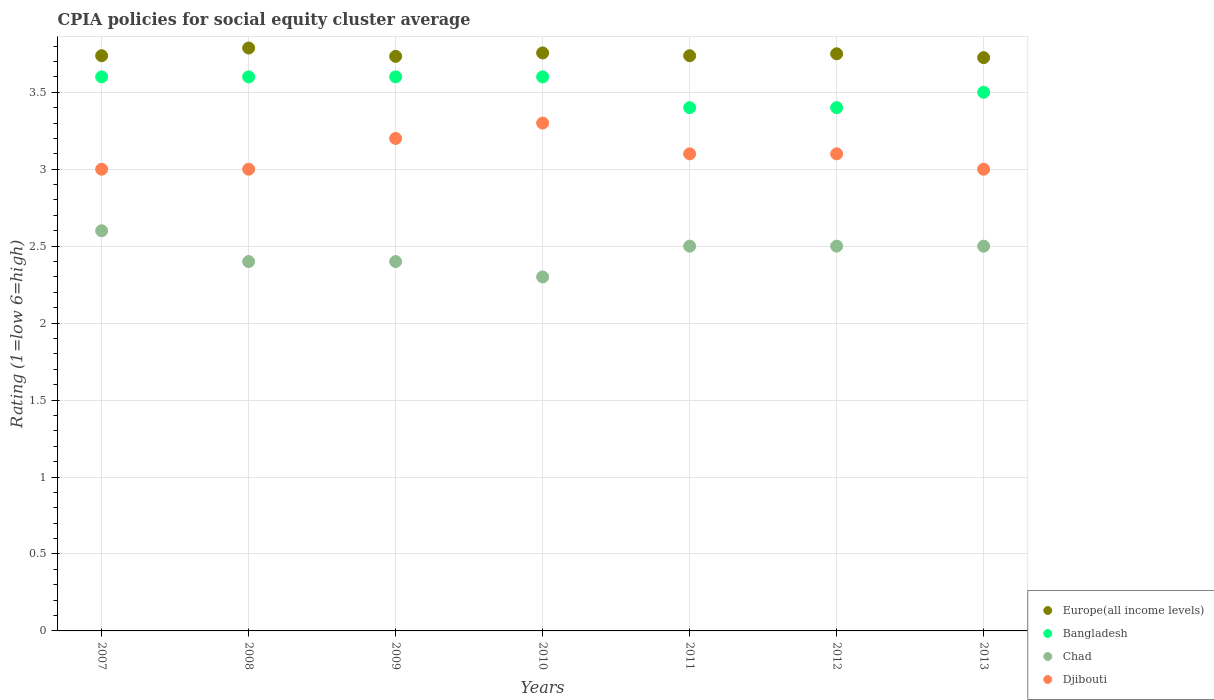How many different coloured dotlines are there?
Your response must be concise. 4. Across all years, what is the minimum CPIA rating in Bangladesh?
Keep it short and to the point. 3.4. In which year was the CPIA rating in Djibouti maximum?
Make the answer very short. 2010. What is the total CPIA rating in Europe(all income levels) in the graph?
Offer a very short reply. 26.23. What is the difference between the CPIA rating in Europe(all income levels) in 2009 and that in 2010?
Provide a short and direct response. -0.02. What is the difference between the CPIA rating in Chad in 2007 and the CPIA rating in Europe(all income levels) in 2012?
Your answer should be compact. -1.15. What is the average CPIA rating in Chad per year?
Ensure brevity in your answer.  2.46. In the year 2010, what is the difference between the CPIA rating in Europe(all income levels) and CPIA rating in Djibouti?
Keep it short and to the point. 0.46. Is the difference between the CPIA rating in Europe(all income levels) in 2011 and 2013 greater than the difference between the CPIA rating in Djibouti in 2011 and 2013?
Provide a succinct answer. No. What is the difference between the highest and the second highest CPIA rating in Chad?
Offer a terse response. 0.1. What is the difference between the highest and the lowest CPIA rating in Djibouti?
Provide a short and direct response. 0.3. Is the sum of the CPIA rating in Bangladesh in 2007 and 2012 greater than the maximum CPIA rating in Chad across all years?
Ensure brevity in your answer.  Yes. Is it the case that in every year, the sum of the CPIA rating in Europe(all income levels) and CPIA rating in Chad  is greater than the sum of CPIA rating in Bangladesh and CPIA rating in Djibouti?
Ensure brevity in your answer.  No. Is it the case that in every year, the sum of the CPIA rating in Chad and CPIA rating in Bangladesh  is greater than the CPIA rating in Europe(all income levels)?
Your answer should be very brief. Yes. Does the CPIA rating in Bangladesh monotonically increase over the years?
Offer a terse response. No. Is the CPIA rating in Europe(all income levels) strictly greater than the CPIA rating in Djibouti over the years?
Offer a terse response. Yes. Is the CPIA rating in Europe(all income levels) strictly less than the CPIA rating in Djibouti over the years?
Offer a very short reply. No. How many years are there in the graph?
Your answer should be compact. 7. Are the values on the major ticks of Y-axis written in scientific E-notation?
Your answer should be very brief. No. Where does the legend appear in the graph?
Keep it short and to the point. Bottom right. How many legend labels are there?
Your answer should be very brief. 4. How are the legend labels stacked?
Your answer should be very brief. Vertical. What is the title of the graph?
Your answer should be very brief. CPIA policies for social equity cluster average. Does "Djibouti" appear as one of the legend labels in the graph?
Keep it short and to the point. Yes. What is the label or title of the X-axis?
Provide a short and direct response. Years. What is the label or title of the Y-axis?
Provide a short and direct response. Rating (1=low 6=high). What is the Rating (1=low 6=high) in Europe(all income levels) in 2007?
Provide a short and direct response. 3.74. What is the Rating (1=low 6=high) of Europe(all income levels) in 2008?
Offer a very short reply. 3.79. What is the Rating (1=low 6=high) in Bangladesh in 2008?
Your answer should be very brief. 3.6. What is the Rating (1=low 6=high) of Europe(all income levels) in 2009?
Keep it short and to the point. 3.73. What is the Rating (1=low 6=high) in Europe(all income levels) in 2010?
Ensure brevity in your answer.  3.76. What is the Rating (1=low 6=high) in Europe(all income levels) in 2011?
Keep it short and to the point. 3.74. What is the Rating (1=low 6=high) of Europe(all income levels) in 2012?
Keep it short and to the point. 3.75. What is the Rating (1=low 6=high) of Bangladesh in 2012?
Provide a succinct answer. 3.4. What is the Rating (1=low 6=high) of Chad in 2012?
Your answer should be compact. 2.5. What is the Rating (1=low 6=high) in Djibouti in 2012?
Offer a very short reply. 3.1. What is the Rating (1=low 6=high) of Europe(all income levels) in 2013?
Your answer should be compact. 3.73. What is the Rating (1=low 6=high) of Bangladesh in 2013?
Offer a very short reply. 3.5. What is the Rating (1=low 6=high) of Chad in 2013?
Your response must be concise. 2.5. What is the Rating (1=low 6=high) in Djibouti in 2013?
Make the answer very short. 3. Across all years, what is the maximum Rating (1=low 6=high) in Europe(all income levels)?
Provide a succinct answer. 3.79. Across all years, what is the minimum Rating (1=low 6=high) of Europe(all income levels)?
Offer a very short reply. 3.73. Across all years, what is the minimum Rating (1=low 6=high) of Chad?
Your answer should be very brief. 2.3. Across all years, what is the minimum Rating (1=low 6=high) in Djibouti?
Give a very brief answer. 3. What is the total Rating (1=low 6=high) in Europe(all income levels) in the graph?
Keep it short and to the point. 26.23. What is the total Rating (1=low 6=high) of Bangladesh in the graph?
Provide a short and direct response. 24.7. What is the total Rating (1=low 6=high) in Djibouti in the graph?
Provide a succinct answer. 21.7. What is the difference between the Rating (1=low 6=high) of Europe(all income levels) in 2007 and that in 2008?
Offer a terse response. -0.05. What is the difference between the Rating (1=low 6=high) in Bangladesh in 2007 and that in 2008?
Offer a very short reply. 0. What is the difference between the Rating (1=low 6=high) of Chad in 2007 and that in 2008?
Ensure brevity in your answer.  0.2. What is the difference between the Rating (1=low 6=high) of Europe(all income levels) in 2007 and that in 2009?
Make the answer very short. 0. What is the difference between the Rating (1=low 6=high) of Bangladesh in 2007 and that in 2009?
Offer a very short reply. 0. What is the difference between the Rating (1=low 6=high) in Chad in 2007 and that in 2009?
Keep it short and to the point. 0.2. What is the difference between the Rating (1=low 6=high) of Europe(all income levels) in 2007 and that in 2010?
Your response must be concise. -0.02. What is the difference between the Rating (1=low 6=high) in Bangladesh in 2007 and that in 2010?
Keep it short and to the point. 0. What is the difference between the Rating (1=low 6=high) in Chad in 2007 and that in 2010?
Make the answer very short. 0.3. What is the difference between the Rating (1=low 6=high) in Chad in 2007 and that in 2011?
Give a very brief answer. 0.1. What is the difference between the Rating (1=low 6=high) in Djibouti in 2007 and that in 2011?
Ensure brevity in your answer.  -0.1. What is the difference between the Rating (1=low 6=high) in Europe(all income levels) in 2007 and that in 2012?
Offer a very short reply. -0.01. What is the difference between the Rating (1=low 6=high) of Bangladesh in 2007 and that in 2012?
Provide a short and direct response. 0.2. What is the difference between the Rating (1=low 6=high) in Europe(all income levels) in 2007 and that in 2013?
Provide a succinct answer. 0.01. What is the difference between the Rating (1=low 6=high) of Chad in 2007 and that in 2013?
Give a very brief answer. 0.1. What is the difference between the Rating (1=low 6=high) of Europe(all income levels) in 2008 and that in 2009?
Your answer should be compact. 0.05. What is the difference between the Rating (1=low 6=high) in Bangladesh in 2008 and that in 2009?
Your answer should be compact. 0. What is the difference between the Rating (1=low 6=high) in Europe(all income levels) in 2008 and that in 2010?
Your answer should be compact. 0.03. What is the difference between the Rating (1=low 6=high) of Djibouti in 2008 and that in 2010?
Your answer should be compact. -0.3. What is the difference between the Rating (1=low 6=high) in Bangladesh in 2008 and that in 2011?
Your response must be concise. 0.2. What is the difference between the Rating (1=low 6=high) of Chad in 2008 and that in 2011?
Give a very brief answer. -0.1. What is the difference between the Rating (1=low 6=high) in Europe(all income levels) in 2008 and that in 2012?
Provide a succinct answer. 0.04. What is the difference between the Rating (1=low 6=high) of Chad in 2008 and that in 2012?
Provide a succinct answer. -0.1. What is the difference between the Rating (1=low 6=high) of Europe(all income levels) in 2008 and that in 2013?
Give a very brief answer. 0.06. What is the difference between the Rating (1=low 6=high) in Chad in 2008 and that in 2013?
Offer a terse response. -0.1. What is the difference between the Rating (1=low 6=high) of Djibouti in 2008 and that in 2013?
Your answer should be compact. 0. What is the difference between the Rating (1=low 6=high) in Europe(all income levels) in 2009 and that in 2010?
Make the answer very short. -0.02. What is the difference between the Rating (1=low 6=high) of Bangladesh in 2009 and that in 2010?
Provide a short and direct response. 0. What is the difference between the Rating (1=low 6=high) in Djibouti in 2009 and that in 2010?
Offer a very short reply. -0.1. What is the difference between the Rating (1=low 6=high) in Europe(all income levels) in 2009 and that in 2011?
Keep it short and to the point. -0. What is the difference between the Rating (1=low 6=high) in Chad in 2009 and that in 2011?
Make the answer very short. -0.1. What is the difference between the Rating (1=low 6=high) of Djibouti in 2009 and that in 2011?
Offer a terse response. 0.1. What is the difference between the Rating (1=low 6=high) of Europe(all income levels) in 2009 and that in 2012?
Provide a succinct answer. -0.02. What is the difference between the Rating (1=low 6=high) of Chad in 2009 and that in 2012?
Offer a terse response. -0.1. What is the difference between the Rating (1=low 6=high) of Djibouti in 2009 and that in 2012?
Your answer should be very brief. 0.1. What is the difference between the Rating (1=low 6=high) in Europe(all income levels) in 2009 and that in 2013?
Make the answer very short. 0.01. What is the difference between the Rating (1=low 6=high) in Djibouti in 2009 and that in 2013?
Keep it short and to the point. 0.2. What is the difference between the Rating (1=low 6=high) of Europe(all income levels) in 2010 and that in 2011?
Make the answer very short. 0.02. What is the difference between the Rating (1=low 6=high) in Chad in 2010 and that in 2011?
Give a very brief answer. -0.2. What is the difference between the Rating (1=low 6=high) in Europe(all income levels) in 2010 and that in 2012?
Keep it short and to the point. 0.01. What is the difference between the Rating (1=low 6=high) in Chad in 2010 and that in 2012?
Give a very brief answer. -0.2. What is the difference between the Rating (1=low 6=high) of Djibouti in 2010 and that in 2012?
Offer a very short reply. 0.2. What is the difference between the Rating (1=low 6=high) in Europe(all income levels) in 2010 and that in 2013?
Ensure brevity in your answer.  0.03. What is the difference between the Rating (1=low 6=high) in Chad in 2010 and that in 2013?
Your answer should be compact. -0.2. What is the difference between the Rating (1=low 6=high) of Europe(all income levels) in 2011 and that in 2012?
Ensure brevity in your answer.  -0.01. What is the difference between the Rating (1=low 6=high) in Chad in 2011 and that in 2012?
Provide a succinct answer. 0. What is the difference between the Rating (1=low 6=high) of Djibouti in 2011 and that in 2012?
Your response must be concise. 0. What is the difference between the Rating (1=low 6=high) of Europe(all income levels) in 2011 and that in 2013?
Give a very brief answer. 0.01. What is the difference between the Rating (1=low 6=high) in Bangladesh in 2011 and that in 2013?
Your answer should be compact. -0.1. What is the difference between the Rating (1=low 6=high) of Djibouti in 2011 and that in 2013?
Provide a short and direct response. 0.1. What is the difference between the Rating (1=low 6=high) of Europe(all income levels) in 2012 and that in 2013?
Your answer should be very brief. 0.03. What is the difference between the Rating (1=low 6=high) in Europe(all income levels) in 2007 and the Rating (1=low 6=high) in Bangladesh in 2008?
Keep it short and to the point. 0.14. What is the difference between the Rating (1=low 6=high) in Europe(all income levels) in 2007 and the Rating (1=low 6=high) in Chad in 2008?
Keep it short and to the point. 1.34. What is the difference between the Rating (1=low 6=high) of Europe(all income levels) in 2007 and the Rating (1=low 6=high) of Djibouti in 2008?
Your response must be concise. 0.74. What is the difference between the Rating (1=low 6=high) in Bangladesh in 2007 and the Rating (1=low 6=high) in Djibouti in 2008?
Provide a short and direct response. 0.6. What is the difference between the Rating (1=low 6=high) in Chad in 2007 and the Rating (1=low 6=high) in Djibouti in 2008?
Your response must be concise. -0.4. What is the difference between the Rating (1=low 6=high) of Europe(all income levels) in 2007 and the Rating (1=low 6=high) of Bangladesh in 2009?
Offer a very short reply. 0.14. What is the difference between the Rating (1=low 6=high) in Europe(all income levels) in 2007 and the Rating (1=low 6=high) in Chad in 2009?
Offer a terse response. 1.34. What is the difference between the Rating (1=low 6=high) of Europe(all income levels) in 2007 and the Rating (1=low 6=high) of Djibouti in 2009?
Make the answer very short. 0.54. What is the difference between the Rating (1=low 6=high) of Bangladesh in 2007 and the Rating (1=low 6=high) of Djibouti in 2009?
Provide a succinct answer. 0.4. What is the difference between the Rating (1=low 6=high) of Chad in 2007 and the Rating (1=low 6=high) of Djibouti in 2009?
Offer a very short reply. -0.6. What is the difference between the Rating (1=low 6=high) in Europe(all income levels) in 2007 and the Rating (1=low 6=high) in Bangladesh in 2010?
Offer a very short reply. 0.14. What is the difference between the Rating (1=low 6=high) of Europe(all income levels) in 2007 and the Rating (1=low 6=high) of Chad in 2010?
Make the answer very short. 1.44. What is the difference between the Rating (1=low 6=high) of Europe(all income levels) in 2007 and the Rating (1=low 6=high) of Djibouti in 2010?
Keep it short and to the point. 0.44. What is the difference between the Rating (1=low 6=high) in Bangladesh in 2007 and the Rating (1=low 6=high) in Chad in 2010?
Offer a terse response. 1.3. What is the difference between the Rating (1=low 6=high) of Europe(all income levels) in 2007 and the Rating (1=low 6=high) of Bangladesh in 2011?
Provide a short and direct response. 0.34. What is the difference between the Rating (1=low 6=high) of Europe(all income levels) in 2007 and the Rating (1=low 6=high) of Chad in 2011?
Your response must be concise. 1.24. What is the difference between the Rating (1=low 6=high) in Europe(all income levels) in 2007 and the Rating (1=low 6=high) in Djibouti in 2011?
Provide a short and direct response. 0.64. What is the difference between the Rating (1=low 6=high) in Bangladesh in 2007 and the Rating (1=low 6=high) in Chad in 2011?
Your answer should be compact. 1.1. What is the difference between the Rating (1=low 6=high) of Europe(all income levels) in 2007 and the Rating (1=low 6=high) of Bangladesh in 2012?
Provide a succinct answer. 0.34. What is the difference between the Rating (1=low 6=high) in Europe(all income levels) in 2007 and the Rating (1=low 6=high) in Chad in 2012?
Keep it short and to the point. 1.24. What is the difference between the Rating (1=low 6=high) in Europe(all income levels) in 2007 and the Rating (1=low 6=high) in Djibouti in 2012?
Provide a short and direct response. 0.64. What is the difference between the Rating (1=low 6=high) of Bangladesh in 2007 and the Rating (1=low 6=high) of Chad in 2012?
Your response must be concise. 1.1. What is the difference between the Rating (1=low 6=high) in Chad in 2007 and the Rating (1=low 6=high) in Djibouti in 2012?
Make the answer very short. -0.5. What is the difference between the Rating (1=low 6=high) of Europe(all income levels) in 2007 and the Rating (1=low 6=high) of Bangladesh in 2013?
Keep it short and to the point. 0.24. What is the difference between the Rating (1=low 6=high) of Europe(all income levels) in 2007 and the Rating (1=low 6=high) of Chad in 2013?
Keep it short and to the point. 1.24. What is the difference between the Rating (1=low 6=high) in Europe(all income levels) in 2007 and the Rating (1=low 6=high) in Djibouti in 2013?
Ensure brevity in your answer.  0.74. What is the difference between the Rating (1=low 6=high) in Europe(all income levels) in 2008 and the Rating (1=low 6=high) in Bangladesh in 2009?
Offer a very short reply. 0.19. What is the difference between the Rating (1=low 6=high) in Europe(all income levels) in 2008 and the Rating (1=low 6=high) in Chad in 2009?
Offer a terse response. 1.39. What is the difference between the Rating (1=low 6=high) in Europe(all income levels) in 2008 and the Rating (1=low 6=high) in Djibouti in 2009?
Your response must be concise. 0.59. What is the difference between the Rating (1=low 6=high) of Bangladesh in 2008 and the Rating (1=low 6=high) of Djibouti in 2009?
Your answer should be compact. 0.4. What is the difference between the Rating (1=low 6=high) of Chad in 2008 and the Rating (1=low 6=high) of Djibouti in 2009?
Make the answer very short. -0.8. What is the difference between the Rating (1=low 6=high) in Europe(all income levels) in 2008 and the Rating (1=low 6=high) in Bangladesh in 2010?
Provide a short and direct response. 0.19. What is the difference between the Rating (1=low 6=high) of Europe(all income levels) in 2008 and the Rating (1=low 6=high) of Chad in 2010?
Keep it short and to the point. 1.49. What is the difference between the Rating (1=low 6=high) in Europe(all income levels) in 2008 and the Rating (1=low 6=high) in Djibouti in 2010?
Make the answer very short. 0.49. What is the difference between the Rating (1=low 6=high) of Bangladesh in 2008 and the Rating (1=low 6=high) of Chad in 2010?
Provide a short and direct response. 1.3. What is the difference between the Rating (1=low 6=high) of Europe(all income levels) in 2008 and the Rating (1=low 6=high) of Bangladesh in 2011?
Your answer should be very brief. 0.39. What is the difference between the Rating (1=low 6=high) of Europe(all income levels) in 2008 and the Rating (1=low 6=high) of Chad in 2011?
Make the answer very short. 1.29. What is the difference between the Rating (1=low 6=high) of Europe(all income levels) in 2008 and the Rating (1=low 6=high) of Djibouti in 2011?
Provide a short and direct response. 0.69. What is the difference between the Rating (1=low 6=high) in Bangladesh in 2008 and the Rating (1=low 6=high) in Chad in 2011?
Make the answer very short. 1.1. What is the difference between the Rating (1=low 6=high) in Europe(all income levels) in 2008 and the Rating (1=low 6=high) in Bangladesh in 2012?
Your answer should be very brief. 0.39. What is the difference between the Rating (1=low 6=high) of Europe(all income levels) in 2008 and the Rating (1=low 6=high) of Chad in 2012?
Offer a terse response. 1.29. What is the difference between the Rating (1=low 6=high) in Europe(all income levels) in 2008 and the Rating (1=low 6=high) in Djibouti in 2012?
Give a very brief answer. 0.69. What is the difference between the Rating (1=low 6=high) in Bangladesh in 2008 and the Rating (1=low 6=high) in Djibouti in 2012?
Your response must be concise. 0.5. What is the difference between the Rating (1=low 6=high) in Europe(all income levels) in 2008 and the Rating (1=low 6=high) in Bangladesh in 2013?
Offer a terse response. 0.29. What is the difference between the Rating (1=low 6=high) of Europe(all income levels) in 2008 and the Rating (1=low 6=high) of Chad in 2013?
Give a very brief answer. 1.29. What is the difference between the Rating (1=low 6=high) in Europe(all income levels) in 2008 and the Rating (1=low 6=high) in Djibouti in 2013?
Your answer should be very brief. 0.79. What is the difference between the Rating (1=low 6=high) in Chad in 2008 and the Rating (1=low 6=high) in Djibouti in 2013?
Provide a succinct answer. -0.6. What is the difference between the Rating (1=low 6=high) of Europe(all income levels) in 2009 and the Rating (1=low 6=high) of Bangladesh in 2010?
Offer a terse response. 0.13. What is the difference between the Rating (1=low 6=high) in Europe(all income levels) in 2009 and the Rating (1=low 6=high) in Chad in 2010?
Offer a very short reply. 1.43. What is the difference between the Rating (1=low 6=high) of Europe(all income levels) in 2009 and the Rating (1=low 6=high) of Djibouti in 2010?
Your response must be concise. 0.43. What is the difference between the Rating (1=low 6=high) in Bangladesh in 2009 and the Rating (1=low 6=high) in Djibouti in 2010?
Keep it short and to the point. 0.3. What is the difference between the Rating (1=low 6=high) in Chad in 2009 and the Rating (1=low 6=high) in Djibouti in 2010?
Keep it short and to the point. -0.9. What is the difference between the Rating (1=low 6=high) of Europe(all income levels) in 2009 and the Rating (1=low 6=high) of Bangladesh in 2011?
Your response must be concise. 0.33. What is the difference between the Rating (1=low 6=high) of Europe(all income levels) in 2009 and the Rating (1=low 6=high) of Chad in 2011?
Your response must be concise. 1.23. What is the difference between the Rating (1=low 6=high) in Europe(all income levels) in 2009 and the Rating (1=low 6=high) in Djibouti in 2011?
Offer a very short reply. 0.63. What is the difference between the Rating (1=low 6=high) of Bangladesh in 2009 and the Rating (1=low 6=high) of Chad in 2011?
Make the answer very short. 1.1. What is the difference between the Rating (1=low 6=high) in Bangladesh in 2009 and the Rating (1=low 6=high) in Djibouti in 2011?
Your answer should be compact. 0.5. What is the difference between the Rating (1=low 6=high) in Europe(all income levels) in 2009 and the Rating (1=low 6=high) in Chad in 2012?
Ensure brevity in your answer.  1.23. What is the difference between the Rating (1=low 6=high) of Europe(all income levels) in 2009 and the Rating (1=low 6=high) of Djibouti in 2012?
Give a very brief answer. 0.63. What is the difference between the Rating (1=low 6=high) in Bangladesh in 2009 and the Rating (1=low 6=high) in Chad in 2012?
Your answer should be compact. 1.1. What is the difference between the Rating (1=low 6=high) of Chad in 2009 and the Rating (1=low 6=high) of Djibouti in 2012?
Provide a succinct answer. -0.7. What is the difference between the Rating (1=low 6=high) in Europe(all income levels) in 2009 and the Rating (1=low 6=high) in Bangladesh in 2013?
Make the answer very short. 0.23. What is the difference between the Rating (1=low 6=high) in Europe(all income levels) in 2009 and the Rating (1=low 6=high) in Chad in 2013?
Offer a terse response. 1.23. What is the difference between the Rating (1=low 6=high) of Europe(all income levels) in 2009 and the Rating (1=low 6=high) of Djibouti in 2013?
Offer a terse response. 0.73. What is the difference between the Rating (1=low 6=high) in Bangladesh in 2009 and the Rating (1=low 6=high) in Chad in 2013?
Ensure brevity in your answer.  1.1. What is the difference between the Rating (1=low 6=high) in Bangladesh in 2009 and the Rating (1=low 6=high) in Djibouti in 2013?
Make the answer very short. 0.6. What is the difference between the Rating (1=low 6=high) of Chad in 2009 and the Rating (1=low 6=high) of Djibouti in 2013?
Give a very brief answer. -0.6. What is the difference between the Rating (1=low 6=high) in Europe(all income levels) in 2010 and the Rating (1=low 6=high) in Bangladesh in 2011?
Make the answer very short. 0.36. What is the difference between the Rating (1=low 6=high) in Europe(all income levels) in 2010 and the Rating (1=low 6=high) in Chad in 2011?
Offer a terse response. 1.26. What is the difference between the Rating (1=low 6=high) of Europe(all income levels) in 2010 and the Rating (1=low 6=high) of Djibouti in 2011?
Your response must be concise. 0.66. What is the difference between the Rating (1=low 6=high) of Europe(all income levels) in 2010 and the Rating (1=low 6=high) of Bangladesh in 2012?
Make the answer very short. 0.36. What is the difference between the Rating (1=low 6=high) of Europe(all income levels) in 2010 and the Rating (1=low 6=high) of Chad in 2012?
Offer a very short reply. 1.26. What is the difference between the Rating (1=low 6=high) in Europe(all income levels) in 2010 and the Rating (1=low 6=high) in Djibouti in 2012?
Offer a terse response. 0.66. What is the difference between the Rating (1=low 6=high) in Bangladesh in 2010 and the Rating (1=low 6=high) in Chad in 2012?
Offer a very short reply. 1.1. What is the difference between the Rating (1=low 6=high) of Chad in 2010 and the Rating (1=low 6=high) of Djibouti in 2012?
Your answer should be very brief. -0.8. What is the difference between the Rating (1=low 6=high) in Europe(all income levels) in 2010 and the Rating (1=low 6=high) in Bangladesh in 2013?
Keep it short and to the point. 0.26. What is the difference between the Rating (1=low 6=high) in Europe(all income levels) in 2010 and the Rating (1=low 6=high) in Chad in 2013?
Your response must be concise. 1.26. What is the difference between the Rating (1=low 6=high) of Europe(all income levels) in 2010 and the Rating (1=low 6=high) of Djibouti in 2013?
Your response must be concise. 0.76. What is the difference between the Rating (1=low 6=high) of Europe(all income levels) in 2011 and the Rating (1=low 6=high) of Bangladesh in 2012?
Your answer should be compact. 0.34. What is the difference between the Rating (1=low 6=high) of Europe(all income levels) in 2011 and the Rating (1=low 6=high) of Chad in 2012?
Your answer should be very brief. 1.24. What is the difference between the Rating (1=low 6=high) in Europe(all income levels) in 2011 and the Rating (1=low 6=high) in Djibouti in 2012?
Provide a short and direct response. 0.64. What is the difference between the Rating (1=low 6=high) in Europe(all income levels) in 2011 and the Rating (1=low 6=high) in Bangladesh in 2013?
Your response must be concise. 0.24. What is the difference between the Rating (1=low 6=high) in Europe(all income levels) in 2011 and the Rating (1=low 6=high) in Chad in 2013?
Your response must be concise. 1.24. What is the difference between the Rating (1=low 6=high) in Europe(all income levels) in 2011 and the Rating (1=low 6=high) in Djibouti in 2013?
Offer a very short reply. 0.74. What is the difference between the Rating (1=low 6=high) in Bangladesh in 2011 and the Rating (1=low 6=high) in Chad in 2013?
Your answer should be very brief. 0.9. What is the difference between the Rating (1=low 6=high) in Bangladesh in 2011 and the Rating (1=low 6=high) in Djibouti in 2013?
Keep it short and to the point. 0.4. What is the difference between the Rating (1=low 6=high) of Europe(all income levels) in 2012 and the Rating (1=low 6=high) of Bangladesh in 2013?
Offer a terse response. 0.25. What is the average Rating (1=low 6=high) of Europe(all income levels) per year?
Ensure brevity in your answer.  3.75. What is the average Rating (1=low 6=high) in Bangladesh per year?
Your answer should be compact. 3.53. What is the average Rating (1=low 6=high) of Chad per year?
Provide a short and direct response. 2.46. In the year 2007, what is the difference between the Rating (1=low 6=high) of Europe(all income levels) and Rating (1=low 6=high) of Bangladesh?
Offer a terse response. 0.14. In the year 2007, what is the difference between the Rating (1=low 6=high) of Europe(all income levels) and Rating (1=low 6=high) of Chad?
Make the answer very short. 1.14. In the year 2007, what is the difference between the Rating (1=low 6=high) in Europe(all income levels) and Rating (1=low 6=high) in Djibouti?
Your response must be concise. 0.74. In the year 2007, what is the difference between the Rating (1=low 6=high) in Bangladesh and Rating (1=low 6=high) in Chad?
Offer a very short reply. 1. In the year 2008, what is the difference between the Rating (1=low 6=high) in Europe(all income levels) and Rating (1=low 6=high) in Bangladesh?
Provide a short and direct response. 0.19. In the year 2008, what is the difference between the Rating (1=low 6=high) in Europe(all income levels) and Rating (1=low 6=high) in Chad?
Offer a very short reply. 1.39. In the year 2008, what is the difference between the Rating (1=low 6=high) of Europe(all income levels) and Rating (1=low 6=high) of Djibouti?
Keep it short and to the point. 0.79. In the year 2008, what is the difference between the Rating (1=low 6=high) in Bangladesh and Rating (1=low 6=high) in Chad?
Your answer should be compact. 1.2. In the year 2008, what is the difference between the Rating (1=low 6=high) in Bangladesh and Rating (1=low 6=high) in Djibouti?
Keep it short and to the point. 0.6. In the year 2009, what is the difference between the Rating (1=low 6=high) of Europe(all income levels) and Rating (1=low 6=high) of Bangladesh?
Offer a terse response. 0.13. In the year 2009, what is the difference between the Rating (1=low 6=high) of Europe(all income levels) and Rating (1=low 6=high) of Djibouti?
Provide a succinct answer. 0.53. In the year 2009, what is the difference between the Rating (1=low 6=high) of Bangladesh and Rating (1=low 6=high) of Djibouti?
Your answer should be compact. 0.4. In the year 2010, what is the difference between the Rating (1=low 6=high) of Europe(all income levels) and Rating (1=low 6=high) of Bangladesh?
Ensure brevity in your answer.  0.16. In the year 2010, what is the difference between the Rating (1=low 6=high) in Europe(all income levels) and Rating (1=low 6=high) in Chad?
Provide a short and direct response. 1.46. In the year 2010, what is the difference between the Rating (1=low 6=high) in Europe(all income levels) and Rating (1=low 6=high) in Djibouti?
Ensure brevity in your answer.  0.46. In the year 2010, what is the difference between the Rating (1=low 6=high) in Bangladesh and Rating (1=low 6=high) in Djibouti?
Provide a short and direct response. 0.3. In the year 2010, what is the difference between the Rating (1=low 6=high) of Chad and Rating (1=low 6=high) of Djibouti?
Ensure brevity in your answer.  -1. In the year 2011, what is the difference between the Rating (1=low 6=high) of Europe(all income levels) and Rating (1=low 6=high) of Bangladesh?
Provide a succinct answer. 0.34. In the year 2011, what is the difference between the Rating (1=low 6=high) of Europe(all income levels) and Rating (1=low 6=high) of Chad?
Give a very brief answer. 1.24. In the year 2011, what is the difference between the Rating (1=low 6=high) in Europe(all income levels) and Rating (1=low 6=high) in Djibouti?
Ensure brevity in your answer.  0.64. In the year 2011, what is the difference between the Rating (1=low 6=high) of Bangladesh and Rating (1=low 6=high) of Chad?
Make the answer very short. 0.9. In the year 2011, what is the difference between the Rating (1=low 6=high) of Bangladesh and Rating (1=low 6=high) of Djibouti?
Your answer should be very brief. 0.3. In the year 2011, what is the difference between the Rating (1=low 6=high) of Chad and Rating (1=low 6=high) of Djibouti?
Your answer should be compact. -0.6. In the year 2012, what is the difference between the Rating (1=low 6=high) in Europe(all income levels) and Rating (1=low 6=high) in Bangladesh?
Ensure brevity in your answer.  0.35. In the year 2012, what is the difference between the Rating (1=low 6=high) in Europe(all income levels) and Rating (1=low 6=high) in Djibouti?
Your answer should be compact. 0.65. In the year 2012, what is the difference between the Rating (1=low 6=high) of Bangladesh and Rating (1=low 6=high) of Djibouti?
Ensure brevity in your answer.  0.3. In the year 2012, what is the difference between the Rating (1=low 6=high) in Chad and Rating (1=low 6=high) in Djibouti?
Your response must be concise. -0.6. In the year 2013, what is the difference between the Rating (1=low 6=high) of Europe(all income levels) and Rating (1=low 6=high) of Bangladesh?
Give a very brief answer. 0.23. In the year 2013, what is the difference between the Rating (1=low 6=high) in Europe(all income levels) and Rating (1=low 6=high) in Chad?
Provide a short and direct response. 1.23. In the year 2013, what is the difference between the Rating (1=low 6=high) in Europe(all income levels) and Rating (1=low 6=high) in Djibouti?
Your response must be concise. 0.72. In the year 2013, what is the difference between the Rating (1=low 6=high) of Bangladesh and Rating (1=low 6=high) of Djibouti?
Give a very brief answer. 0.5. In the year 2013, what is the difference between the Rating (1=low 6=high) in Chad and Rating (1=low 6=high) in Djibouti?
Make the answer very short. -0.5. What is the ratio of the Rating (1=low 6=high) of Bangladesh in 2007 to that in 2008?
Provide a short and direct response. 1. What is the ratio of the Rating (1=low 6=high) of Chad in 2007 to that in 2008?
Your answer should be very brief. 1.08. What is the ratio of the Rating (1=low 6=high) of Djibouti in 2007 to that in 2008?
Provide a short and direct response. 1. What is the ratio of the Rating (1=low 6=high) of Europe(all income levels) in 2007 to that in 2009?
Ensure brevity in your answer.  1. What is the ratio of the Rating (1=low 6=high) in Chad in 2007 to that in 2009?
Ensure brevity in your answer.  1.08. What is the ratio of the Rating (1=low 6=high) in Europe(all income levels) in 2007 to that in 2010?
Ensure brevity in your answer.  1. What is the ratio of the Rating (1=low 6=high) of Chad in 2007 to that in 2010?
Provide a succinct answer. 1.13. What is the ratio of the Rating (1=low 6=high) of Europe(all income levels) in 2007 to that in 2011?
Keep it short and to the point. 1. What is the ratio of the Rating (1=low 6=high) in Bangladesh in 2007 to that in 2011?
Provide a short and direct response. 1.06. What is the ratio of the Rating (1=low 6=high) in Chad in 2007 to that in 2011?
Keep it short and to the point. 1.04. What is the ratio of the Rating (1=low 6=high) in Bangladesh in 2007 to that in 2012?
Provide a short and direct response. 1.06. What is the ratio of the Rating (1=low 6=high) in Europe(all income levels) in 2007 to that in 2013?
Your response must be concise. 1. What is the ratio of the Rating (1=low 6=high) of Bangladesh in 2007 to that in 2013?
Offer a terse response. 1.03. What is the ratio of the Rating (1=low 6=high) in Chad in 2007 to that in 2013?
Make the answer very short. 1.04. What is the ratio of the Rating (1=low 6=high) in Djibouti in 2007 to that in 2013?
Provide a succinct answer. 1. What is the ratio of the Rating (1=low 6=high) in Europe(all income levels) in 2008 to that in 2009?
Offer a terse response. 1.01. What is the ratio of the Rating (1=low 6=high) in Bangladesh in 2008 to that in 2009?
Make the answer very short. 1. What is the ratio of the Rating (1=low 6=high) in Djibouti in 2008 to that in 2009?
Provide a short and direct response. 0.94. What is the ratio of the Rating (1=low 6=high) of Europe(all income levels) in 2008 to that in 2010?
Your answer should be very brief. 1.01. What is the ratio of the Rating (1=low 6=high) in Bangladesh in 2008 to that in 2010?
Offer a very short reply. 1. What is the ratio of the Rating (1=low 6=high) of Chad in 2008 to that in 2010?
Offer a very short reply. 1.04. What is the ratio of the Rating (1=low 6=high) in Djibouti in 2008 to that in 2010?
Provide a succinct answer. 0.91. What is the ratio of the Rating (1=low 6=high) in Europe(all income levels) in 2008 to that in 2011?
Your answer should be very brief. 1.01. What is the ratio of the Rating (1=low 6=high) in Bangladesh in 2008 to that in 2011?
Keep it short and to the point. 1.06. What is the ratio of the Rating (1=low 6=high) in Chad in 2008 to that in 2011?
Your answer should be compact. 0.96. What is the ratio of the Rating (1=low 6=high) in Djibouti in 2008 to that in 2011?
Give a very brief answer. 0.97. What is the ratio of the Rating (1=low 6=high) of Europe(all income levels) in 2008 to that in 2012?
Make the answer very short. 1.01. What is the ratio of the Rating (1=low 6=high) in Bangladesh in 2008 to that in 2012?
Provide a succinct answer. 1.06. What is the ratio of the Rating (1=low 6=high) in Chad in 2008 to that in 2012?
Keep it short and to the point. 0.96. What is the ratio of the Rating (1=low 6=high) of Europe(all income levels) in 2008 to that in 2013?
Offer a very short reply. 1.02. What is the ratio of the Rating (1=low 6=high) in Bangladesh in 2008 to that in 2013?
Give a very brief answer. 1.03. What is the ratio of the Rating (1=low 6=high) of Djibouti in 2008 to that in 2013?
Make the answer very short. 1. What is the ratio of the Rating (1=low 6=high) in Europe(all income levels) in 2009 to that in 2010?
Your response must be concise. 0.99. What is the ratio of the Rating (1=low 6=high) in Bangladesh in 2009 to that in 2010?
Offer a terse response. 1. What is the ratio of the Rating (1=low 6=high) of Chad in 2009 to that in 2010?
Offer a terse response. 1.04. What is the ratio of the Rating (1=low 6=high) in Djibouti in 2009 to that in 2010?
Your answer should be very brief. 0.97. What is the ratio of the Rating (1=low 6=high) in Europe(all income levels) in 2009 to that in 2011?
Offer a very short reply. 1. What is the ratio of the Rating (1=low 6=high) in Bangladesh in 2009 to that in 2011?
Offer a very short reply. 1.06. What is the ratio of the Rating (1=low 6=high) in Chad in 2009 to that in 2011?
Your answer should be compact. 0.96. What is the ratio of the Rating (1=low 6=high) of Djibouti in 2009 to that in 2011?
Your answer should be very brief. 1.03. What is the ratio of the Rating (1=low 6=high) of Bangladesh in 2009 to that in 2012?
Give a very brief answer. 1.06. What is the ratio of the Rating (1=low 6=high) of Djibouti in 2009 to that in 2012?
Give a very brief answer. 1.03. What is the ratio of the Rating (1=low 6=high) in Bangladesh in 2009 to that in 2013?
Offer a terse response. 1.03. What is the ratio of the Rating (1=low 6=high) in Chad in 2009 to that in 2013?
Provide a succinct answer. 0.96. What is the ratio of the Rating (1=low 6=high) in Djibouti in 2009 to that in 2013?
Give a very brief answer. 1.07. What is the ratio of the Rating (1=low 6=high) of Europe(all income levels) in 2010 to that in 2011?
Your response must be concise. 1. What is the ratio of the Rating (1=low 6=high) of Bangladesh in 2010 to that in 2011?
Ensure brevity in your answer.  1.06. What is the ratio of the Rating (1=low 6=high) of Djibouti in 2010 to that in 2011?
Offer a terse response. 1.06. What is the ratio of the Rating (1=low 6=high) of Bangladesh in 2010 to that in 2012?
Ensure brevity in your answer.  1.06. What is the ratio of the Rating (1=low 6=high) in Chad in 2010 to that in 2012?
Your answer should be compact. 0.92. What is the ratio of the Rating (1=low 6=high) in Djibouti in 2010 to that in 2012?
Give a very brief answer. 1.06. What is the ratio of the Rating (1=low 6=high) of Europe(all income levels) in 2010 to that in 2013?
Give a very brief answer. 1.01. What is the ratio of the Rating (1=low 6=high) of Bangladesh in 2010 to that in 2013?
Give a very brief answer. 1.03. What is the ratio of the Rating (1=low 6=high) of Chad in 2010 to that in 2013?
Offer a terse response. 0.92. What is the ratio of the Rating (1=low 6=high) of Europe(all income levels) in 2011 to that in 2012?
Provide a succinct answer. 1. What is the ratio of the Rating (1=low 6=high) in Bangladesh in 2011 to that in 2012?
Offer a terse response. 1. What is the ratio of the Rating (1=low 6=high) in Chad in 2011 to that in 2012?
Provide a succinct answer. 1. What is the ratio of the Rating (1=low 6=high) of Europe(all income levels) in 2011 to that in 2013?
Provide a short and direct response. 1. What is the ratio of the Rating (1=low 6=high) in Bangladesh in 2011 to that in 2013?
Your answer should be very brief. 0.97. What is the ratio of the Rating (1=low 6=high) of Bangladesh in 2012 to that in 2013?
Make the answer very short. 0.97. What is the ratio of the Rating (1=low 6=high) of Chad in 2012 to that in 2013?
Give a very brief answer. 1. What is the difference between the highest and the second highest Rating (1=low 6=high) of Europe(all income levels)?
Ensure brevity in your answer.  0.03. What is the difference between the highest and the second highest Rating (1=low 6=high) of Bangladesh?
Give a very brief answer. 0. What is the difference between the highest and the second highest Rating (1=low 6=high) in Chad?
Make the answer very short. 0.1. What is the difference between the highest and the second highest Rating (1=low 6=high) in Djibouti?
Keep it short and to the point. 0.1. What is the difference between the highest and the lowest Rating (1=low 6=high) of Europe(all income levels)?
Provide a succinct answer. 0.06. What is the difference between the highest and the lowest Rating (1=low 6=high) in Bangladesh?
Your answer should be compact. 0.2. What is the difference between the highest and the lowest Rating (1=low 6=high) of Djibouti?
Your response must be concise. 0.3. 